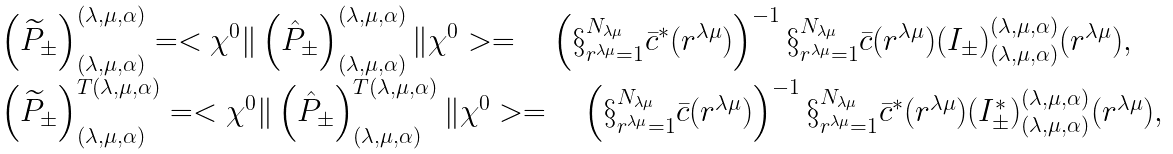Convert formula to latex. <formula><loc_0><loc_0><loc_500><loc_500>\begin{array} { l l } \left ( { \widetilde { P } } _ { \pm } \right ) ^ { ( \lambda , \mu , \alpha ) } _ { ( \lambda , \mu , \alpha ) } = < \chi ^ { 0 } \| \left ( { \hat { P } } _ { \pm } \right ) ^ { ( \lambda , \mu , \alpha ) } _ { ( \lambda , \mu , \alpha ) } \| \chi ^ { 0 } > = \quad \left ( \S _ { r ^ { \lambda \mu } = 1 } ^ { N _ { \lambda \mu } } { \bar { c } } ^ { * } ( r ^ { \lambda \mu } ) \right ) ^ { - 1 } \S _ { r ^ { \lambda \mu } = 1 } ^ { N _ { \lambda \mu } } \bar { c } ( r ^ { \lambda \mu } ) { ( I _ { \pm } ) } ^ { ( \lambda , \mu , \alpha ) } _ { ( \lambda , \mu , \alpha ) } ( r ^ { \lambda \mu } ) , \\ \left ( { \widetilde { P } } _ { \pm } \right ) ^ { T ( \lambda , \mu , \alpha ) } _ { ( \lambda , \mu , \alpha ) } = < \chi ^ { 0 } \| \left ( { \hat { P } } _ { \pm } \right ) ^ { T ( \lambda , \mu , \alpha ) } _ { ( \lambda , \mu , \alpha ) } \| \chi ^ { 0 } > = \quad \left ( \S _ { r ^ { \lambda \mu } = 1 } ^ { N _ { \lambda \mu } } \bar { c } ( r ^ { \lambda \mu } ) \right ) ^ { - 1 } \S _ { r ^ { \lambda \mu } = 1 } ^ { N _ { \lambda \mu } } { \bar { c } } ^ { * } ( r ^ { \lambda \mu } ) { ( I _ { \pm } ^ { * } ) } ^ { ( \lambda , \mu , \alpha ) } _ { ( \lambda , \mu , \alpha ) } ( r ^ { \lambda \mu } ) , \end{array}</formula> 